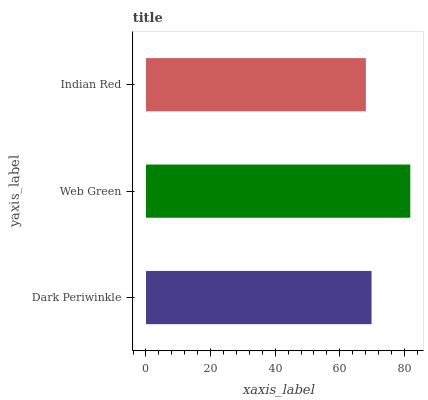Is Indian Red the minimum?
Answer yes or no. Yes. Is Web Green the maximum?
Answer yes or no. Yes. Is Web Green the minimum?
Answer yes or no. No. Is Indian Red the maximum?
Answer yes or no. No. Is Web Green greater than Indian Red?
Answer yes or no. Yes. Is Indian Red less than Web Green?
Answer yes or no. Yes. Is Indian Red greater than Web Green?
Answer yes or no. No. Is Web Green less than Indian Red?
Answer yes or no. No. Is Dark Periwinkle the high median?
Answer yes or no. Yes. Is Dark Periwinkle the low median?
Answer yes or no. Yes. Is Indian Red the high median?
Answer yes or no. No. Is Indian Red the low median?
Answer yes or no. No. 